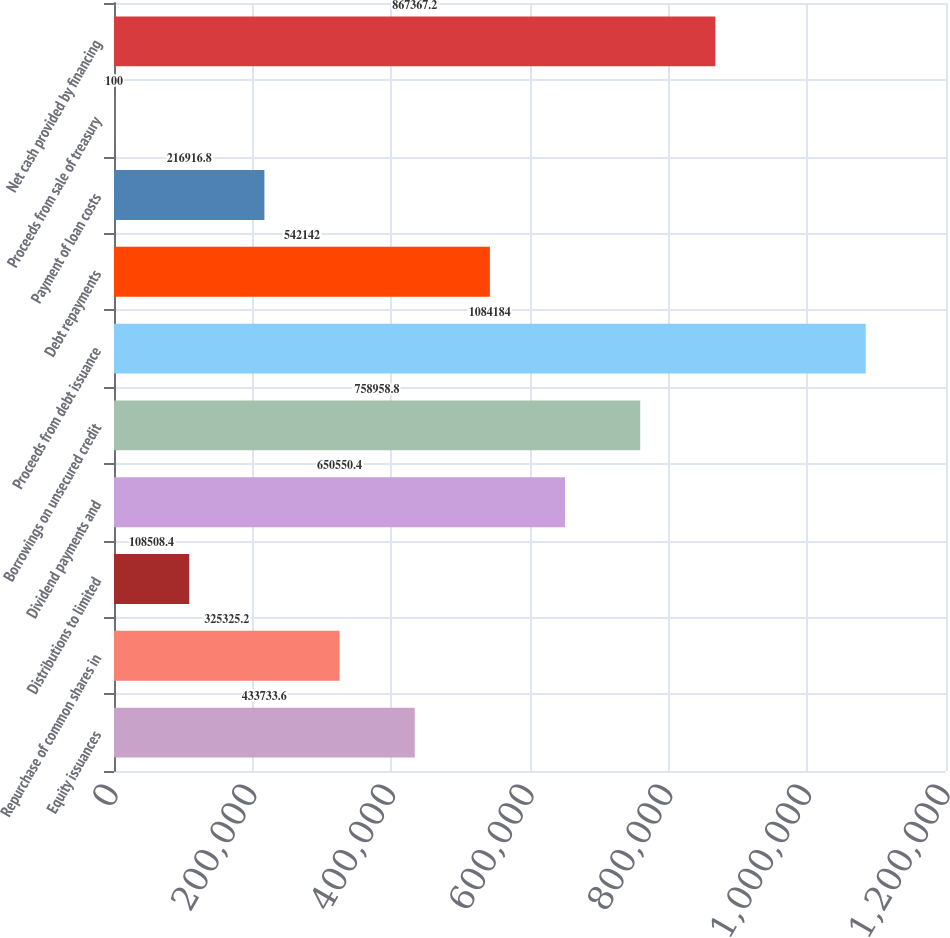<chart> <loc_0><loc_0><loc_500><loc_500><bar_chart><fcel>Equity issuances<fcel>Repurchase of common shares in<fcel>Distributions to limited<fcel>Dividend payments and<fcel>Borrowings on unsecured credit<fcel>Proceeds from debt issuance<fcel>Debt repayments<fcel>Payment of loan costs<fcel>Proceeds from sale of treasury<fcel>Net cash provided by financing<nl><fcel>433734<fcel>325325<fcel>108508<fcel>650550<fcel>758959<fcel>1.08418e+06<fcel>542142<fcel>216917<fcel>100<fcel>867367<nl></chart> 